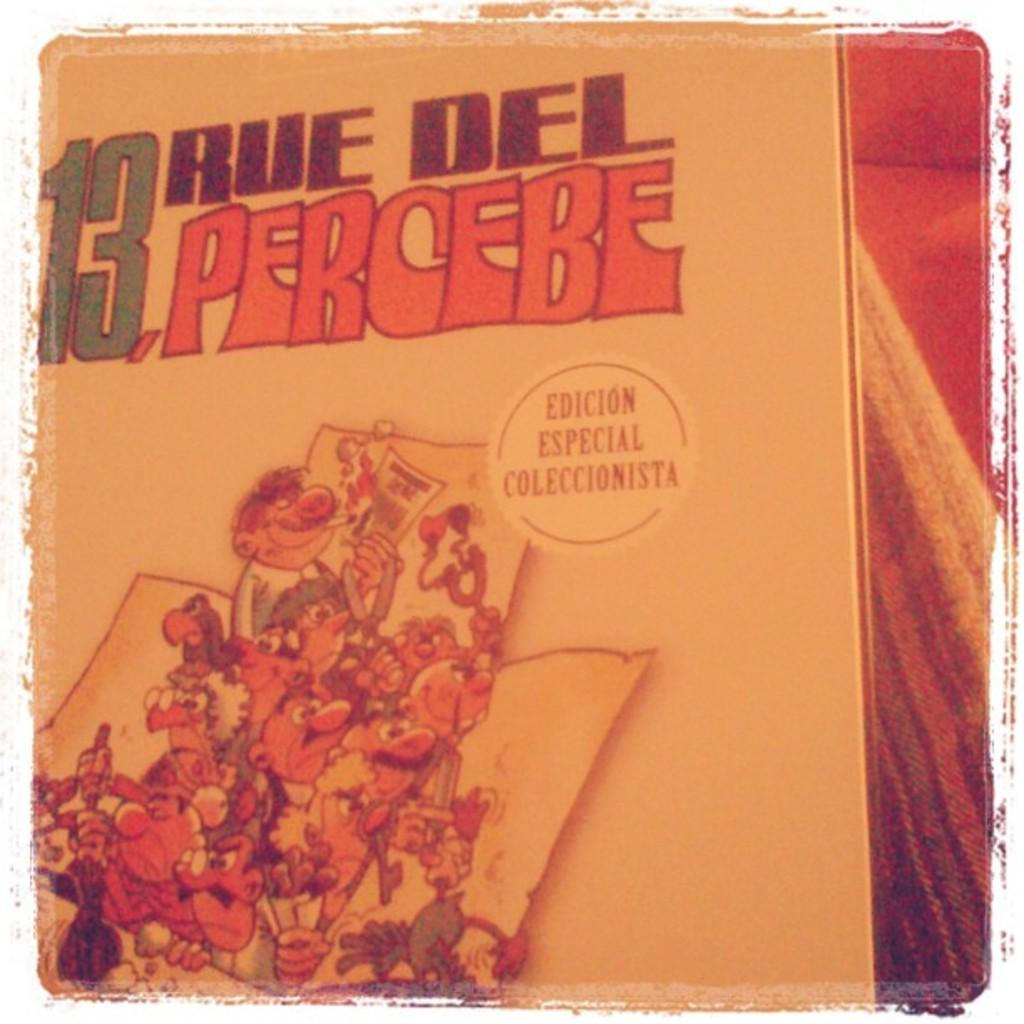What is the main subject of the image? The main subject of the image is a painting. What is the name of the painting? The painting has the name "13 percebe". What type of images are depicted on the painting? There are cartoon pictures on the painting. What language is the painting's name written in? The painting's name, "13 percebe", is written in Spanish. Can you tell me how the painting is helping the plants grow in the image? There are no plants present in the image, and the painting is not depicted as having any effect on plant growth. 